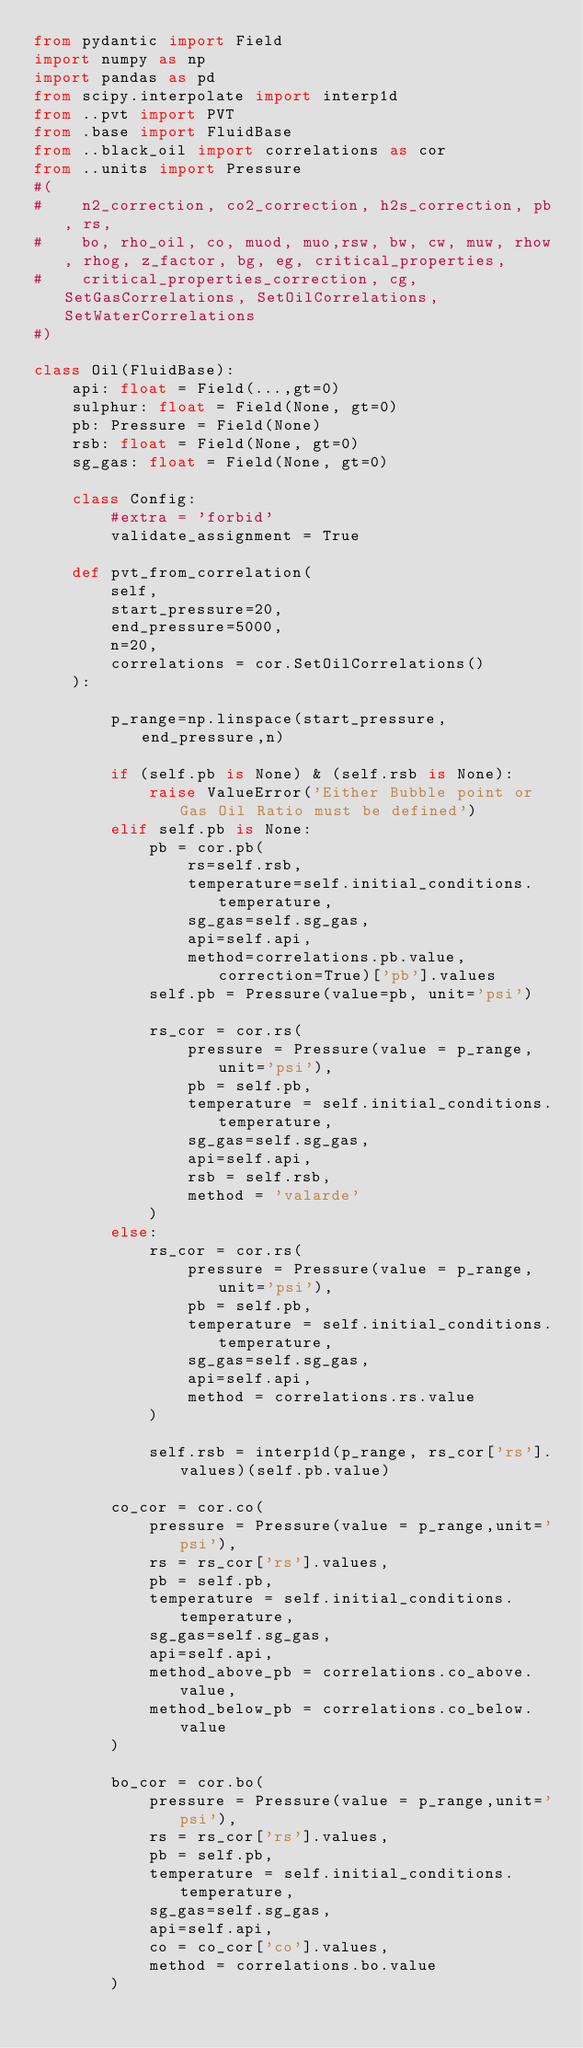Convert code to text. <code><loc_0><loc_0><loc_500><loc_500><_Python_>from pydantic import Field
import numpy as np
import pandas as pd
from scipy.interpolate import interp1d
from ..pvt import PVT
from .base import FluidBase
from ..black_oil import correlations as cor 
from ..units import Pressure
#(
#    n2_correction, co2_correction, h2s_correction, pb, rs,
#    bo, rho_oil, co, muod, muo,rsw, bw, cw, muw, rhow, rhog, z_factor, bg, eg, critical_properties,
#    critical_properties_correction, cg, SetGasCorrelations, SetOilCorrelations, SetWaterCorrelations
#)

class Oil(FluidBase):
    api: float = Field(...,gt=0)
    sulphur: float = Field(None, gt=0)
    pb: Pressure = Field(None)
    rsb: float = Field(None, gt=0)
    sg_gas: float = Field(None, gt=0)
    
    class Config:
        #extra = 'forbid'
        validate_assignment = True
    
    def pvt_from_correlation(
        self,
        start_pressure=20,
        end_pressure=5000,
        n=20,
        correlations = cor.SetOilCorrelations()
    ):
    
        p_range=np.linspace(start_pressure,end_pressure,n)
        
        if (self.pb is None) & (self.rsb is None):
            raise ValueError('Either Bubble point or Gas Oil Ratio must be defined')
        elif self.pb is None:
            pb = cor.pb(
                rs=self.rsb,
                temperature=self.initial_conditions.temperature,
                sg_gas=self.sg_gas,
                api=self.api,
                method=correlations.pb.value, correction=True)['pb'].values
            self.pb = Pressure(value=pb, unit='psi')
            
            rs_cor = cor.rs(
                pressure = Pressure(value = p_range,unit='psi'),
                pb = self.pb,
                temperature = self.initial_conditions.temperature,
                sg_gas=self.sg_gas,
                api=self.api,
                rsb = self.rsb,
                method = 'valarde'
            )
        else:
            rs_cor = cor.rs(
                pressure = Pressure(value = p_range,unit='psi'),
                pb = self.pb,
                temperature = self.initial_conditions.temperature,
                sg_gas=self.sg_gas,
                api=self.api,
                method = correlations.rs.value
            )
            
            self.rsb = interp1d(p_range, rs_cor['rs'].values)(self.pb.value)

        co_cor = cor.co(
            pressure = Pressure(value = p_range,unit='psi'),
            rs = rs_cor['rs'].values,
            pb = self.pb,
            temperature = self.initial_conditions.temperature,
            sg_gas=self.sg_gas,
            api=self.api,
            method_above_pb = correlations.co_above.value,
            method_below_pb = correlations.co_below.value             
        )
        
        bo_cor = cor.bo(
            pressure = Pressure(value = p_range,unit='psi'),
            rs = rs_cor['rs'].values,
            pb = self.pb,
            temperature = self.initial_conditions.temperature,
            sg_gas=self.sg_gas,
            api=self.api,
            co = co_cor['co'].values,
            method = correlations.bo.value
        )
        </code> 